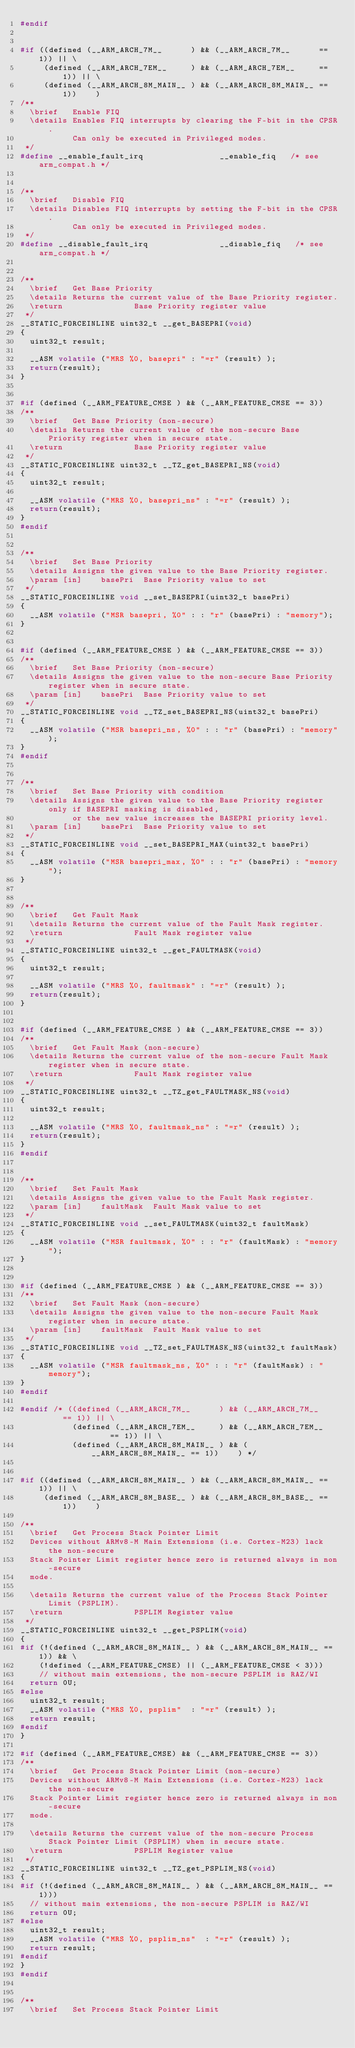<code> <loc_0><loc_0><loc_500><loc_500><_C_>#endif


#if ((defined (__ARM_ARCH_7M__      ) && (__ARM_ARCH_7M__      == 1)) || \
     (defined (__ARM_ARCH_7EM__     ) && (__ARM_ARCH_7EM__     == 1)) || \
     (defined (__ARM_ARCH_8M_MAIN__ ) && (__ARM_ARCH_8M_MAIN__ == 1))    )
/**
  \brief   Enable FIQ
  \details Enables FIQ interrupts by clearing the F-bit in the CPSR.
           Can only be executed in Privileged modes.
 */
#define __enable_fault_irq                __enable_fiq   /* see arm_compat.h */


/**
  \brief   Disable FIQ
  \details Disables FIQ interrupts by setting the F-bit in the CPSR.
           Can only be executed in Privileged modes.
 */
#define __disable_fault_irq               __disable_fiq   /* see arm_compat.h */


/**
  \brief   Get Base Priority
  \details Returns the current value of the Base Priority register.
  \return               Base Priority register value
 */
__STATIC_FORCEINLINE uint32_t __get_BASEPRI(void)
{
  uint32_t result;

  __ASM volatile ("MRS %0, basepri" : "=r" (result) );
  return(result);
}


#if (defined (__ARM_FEATURE_CMSE ) && (__ARM_FEATURE_CMSE == 3))
/**
  \brief   Get Base Priority (non-secure)
  \details Returns the current value of the non-secure Base Priority register when in secure state.
  \return               Base Priority register value
 */
__STATIC_FORCEINLINE uint32_t __TZ_get_BASEPRI_NS(void)
{
  uint32_t result;

  __ASM volatile ("MRS %0, basepri_ns" : "=r" (result) );
  return(result);
}
#endif


/**
  \brief   Set Base Priority
  \details Assigns the given value to the Base Priority register.
  \param [in]    basePri  Base Priority value to set
 */
__STATIC_FORCEINLINE void __set_BASEPRI(uint32_t basePri)
{
  __ASM volatile ("MSR basepri, %0" : : "r" (basePri) : "memory");
}


#if (defined (__ARM_FEATURE_CMSE ) && (__ARM_FEATURE_CMSE == 3))
/**
  \brief   Set Base Priority (non-secure)
  \details Assigns the given value to the non-secure Base Priority register when in secure state.
  \param [in]    basePri  Base Priority value to set
 */
__STATIC_FORCEINLINE void __TZ_set_BASEPRI_NS(uint32_t basePri)
{
  __ASM volatile ("MSR basepri_ns, %0" : : "r" (basePri) : "memory");
}
#endif


/**
  \brief   Set Base Priority with condition
  \details Assigns the given value to the Base Priority register only if BASEPRI masking is disabled,
           or the new value increases the BASEPRI priority level.
  \param [in]    basePri  Base Priority value to set
 */
__STATIC_FORCEINLINE void __set_BASEPRI_MAX(uint32_t basePri)
{
  __ASM volatile ("MSR basepri_max, %0" : : "r" (basePri) : "memory");
}


/**
  \brief   Get Fault Mask
  \details Returns the current value of the Fault Mask register.
  \return               Fault Mask register value
 */
__STATIC_FORCEINLINE uint32_t __get_FAULTMASK(void)
{
  uint32_t result;

  __ASM volatile ("MRS %0, faultmask" : "=r" (result) );
  return(result);
}


#if (defined (__ARM_FEATURE_CMSE ) && (__ARM_FEATURE_CMSE == 3))
/**
  \brief   Get Fault Mask (non-secure)
  \details Returns the current value of the non-secure Fault Mask register when in secure state.
  \return               Fault Mask register value
 */
__STATIC_FORCEINLINE uint32_t __TZ_get_FAULTMASK_NS(void)
{
  uint32_t result;

  __ASM volatile ("MRS %0, faultmask_ns" : "=r" (result) );
  return(result);
}
#endif


/**
  \brief   Set Fault Mask
  \details Assigns the given value to the Fault Mask register.
  \param [in]    faultMask  Fault Mask value to set
 */
__STATIC_FORCEINLINE void __set_FAULTMASK(uint32_t faultMask)
{
  __ASM volatile ("MSR faultmask, %0" : : "r" (faultMask) : "memory");
}


#if (defined (__ARM_FEATURE_CMSE ) && (__ARM_FEATURE_CMSE == 3))
/**
  \brief   Set Fault Mask (non-secure)
  \details Assigns the given value to the non-secure Fault Mask register when in secure state.
  \param [in]    faultMask  Fault Mask value to set
 */
__STATIC_FORCEINLINE void __TZ_set_FAULTMASK_NS(uint32_t faultMask)
{
  __ASM volatile ("MSR faultmask_ns, %0" : : "r" (faultMask) : "memory");
}
#endif

#endif /* ((defined (__ARM_ARCH_7M__      ) && (__ARM_ARCH_7M__      == 1)) || \
           (defined (__ARM_ARCH_7EM__     ) && (__ARM_ARCH_7EM__     == 1)) || \
           (defined (__ARM_ARCH_8M_MAIN__ ) && (__ARM_ARCH_8M_MAIN__ == 1))    ) */


#if ((defined (__ARM_ARCH_8M_MAIN__ ) && (__ARM_ARCH_8M_MAIN__ == 1)) || \
     (defined (__ARM_ARCH_8M_BASE__ ) && (__ARM_ARCH_8M_BASE__ == 1))    )

/**
  \brief   Get Process Stack Pointer Limit
  Devices without ARMv8-M Main Extensions (i.e. Cortex-M23) lack the non-secure
  Stack Pointer Limit register hence zero is returned always in non-secure
  mode.
  
  \details Returns the current value of the Process Stack Pointer Limit (PSPLIM).
  \return               PSPLIM Register value
 */
__STATIC_FORCEINLINE uint32_t __get_PSPLIM(void)
{
#if (!(defined (__ARM_ARCH_8M_MAIN__ ) && (__ARM_ARCH_8M_MAIN__ == 1)) && \
    (!defined (__ARM_FEATURE_CMSE) || (__ARM_FEATURE_CMSE < 3)))
    // without main extensions, the non-secure PSPLIM is RAZ/WI
  return 0U;
#else
  uint32_t result;
  __ASM volatile ("MRS %0, psplim"  : "=r" (result) );
  return result;
#endif
}

#if (defined (__ARM_FEATURE_CMSE) && (__ARM_FEATURE_CMSE == 3))
/**
  \brief   Get Process Stack Pointer Limit (non-secure)
  Devices without ARMv8-M Main Extensions (i.e. Cortex-M23) lack the non-secure
  Stack Pointer Limit register hence zero is returned always in non-secure
  mode.

  \details Returns the current value of the non-secure Process Stack Pointer Limit (PSPLIM) when in secure state.
  \return               PSPLIM Register value
 */
__STATIC_FORCEINLINE uint32_t __TZ_get_PSPLIM_NS(void)
{
#if (!(defined (__ARM_ARCH_8M_MAIN__ ) && (__ARM_ARCH_8M_MAIN__ == 1)))
  // without main extensions, the non-secure PSPLIM is RAZ/WI
  return 0U;
#else
  uint32_t result;
  __ASM volatile ("MRS %0, psplim_ns"  : "=r" (result) );
  return result;
#endif
}
#endif


/**
  \brief   Set Process Stack Pointer Limit</code> 